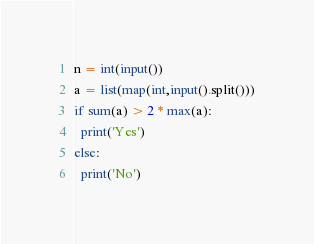<code> <loc_0><loc_0><loc_500><loc_500><_Python_>n = int(input())
a = list(map(int,input().split()))
if sum(a) > 2 * max(a):
  print('Yes')
else:
  print('No')</code> 